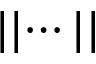Convert formula to latex. <formula><loc_0><loc_0><loc_500><loc_500>| | \cdots | |</formula> 